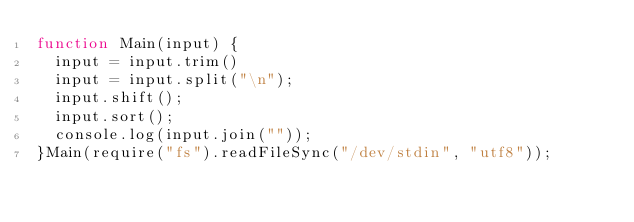Convert code to text. <code><loc_0><loc_0><loc_500><loc_500><_JavaScript_>function Main(input) {
  input = input.trim()
  input = input.split("\n");
  input.shift();
  input.sort();
  console.log(input.join(""));
}Main(require("fs").readFileSync("/dev/stdin", "utf8"));</code> 